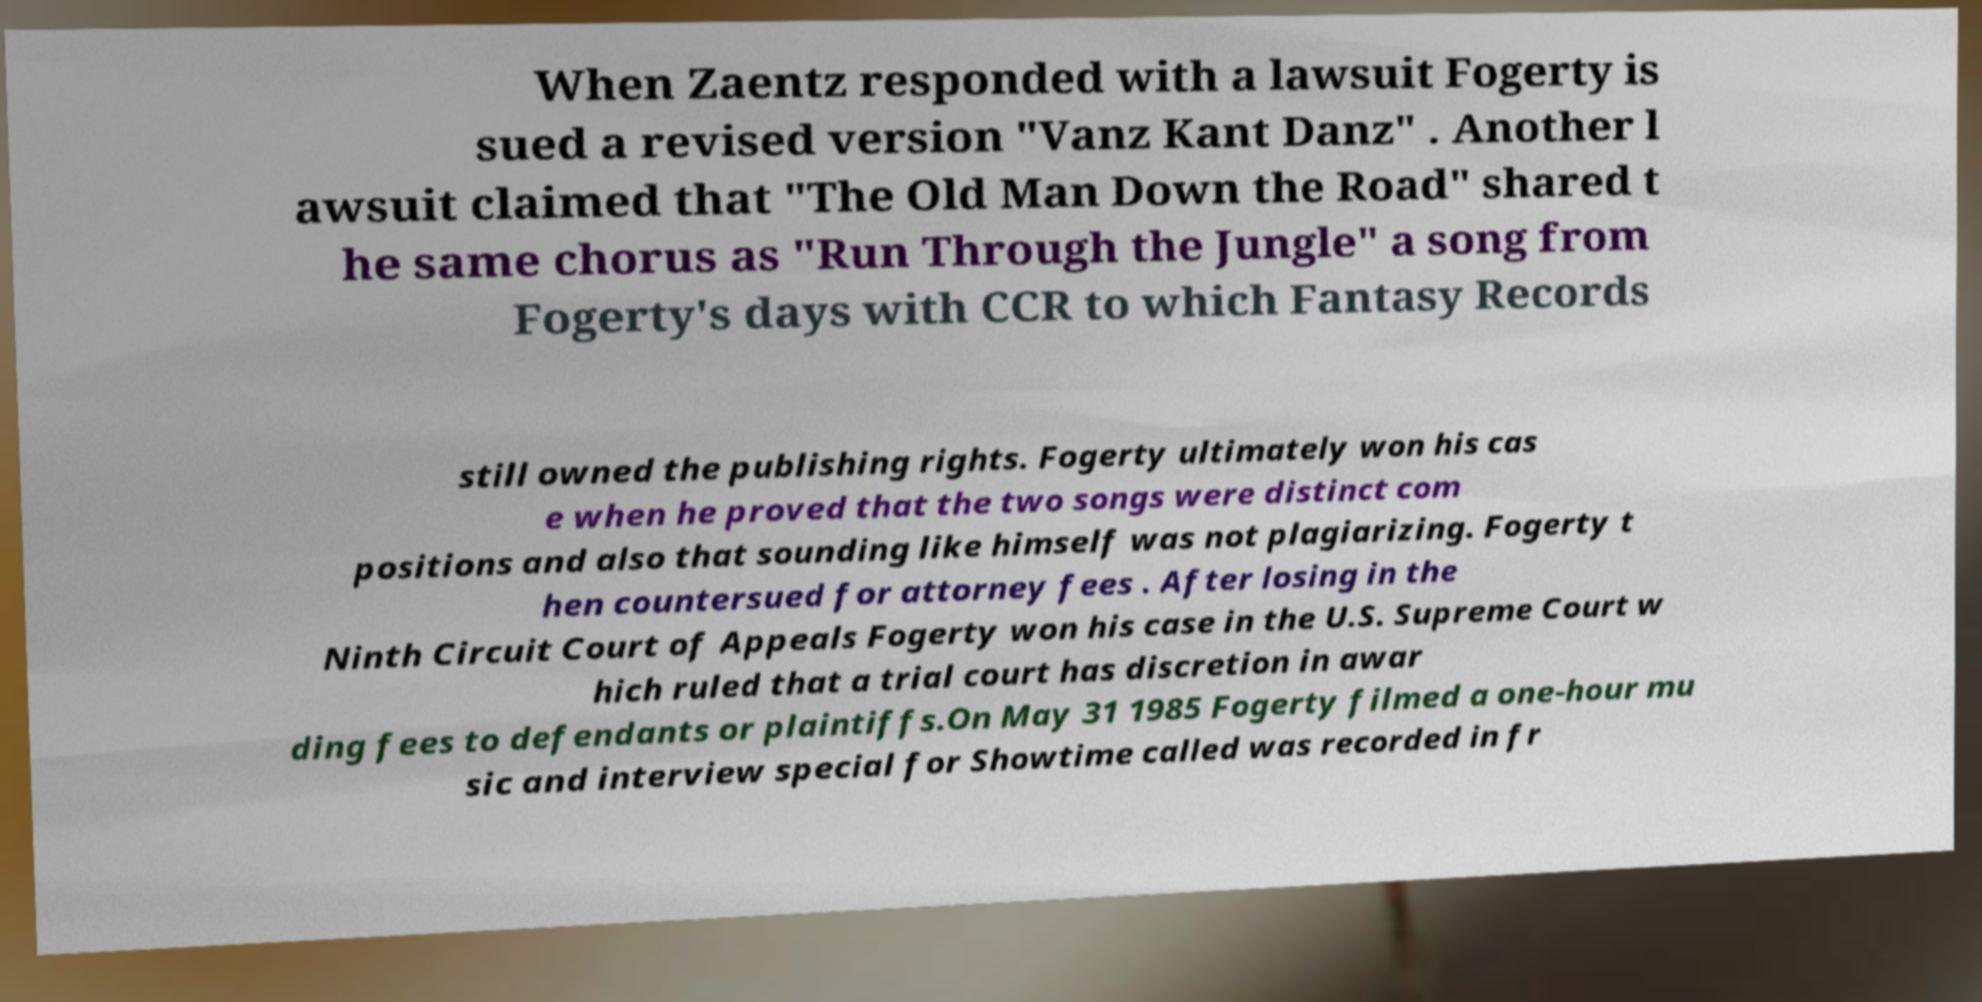Please read and relay the text visible in this image. What does it say? When Zaentz responded with a lawsuit Fogerty is sued a revised version "Vanz Kant Danz" . Another l awsuit claimed that "The Old Man Down the Road" shared t he same chorus as "Run Through the Jungle" a song from Fogerty's days with CCR to which Fantasy Records still owned the publishing rights. Fogerty ultimately won his cas e when he proved that the two songs were distinct com positions and also that sounding like himself was not plagiarizing. Fogerty t hen countersued for attorney fees . After losing in the Ninth Circuit Court of Appeals Fogerty won his case in the U.S. Supreme Court w hich ruled that a trial court has discretion in awar ding fees to defendants or plaintiffs.On May 31 1985 Fogerty filmed a one-hour mu sic and interview special for Showtime called was recorded in fr 